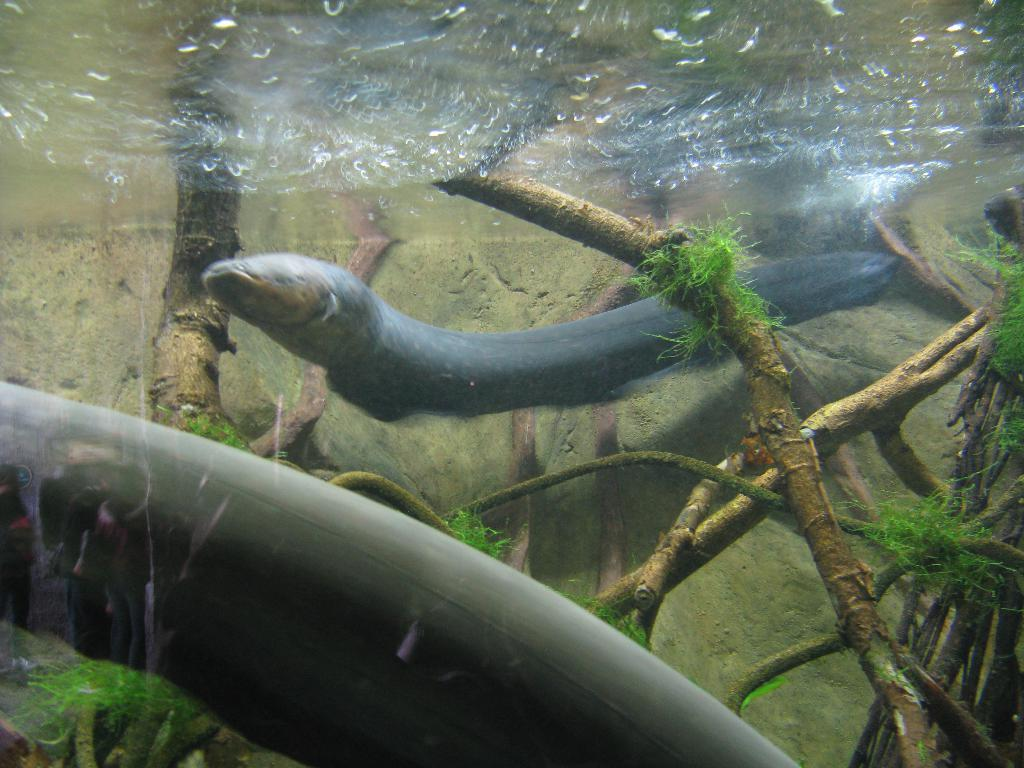Where was the image taken? The image is taken inside the water. What is the main subject in the center of the image? There is an animal in the center of the image. What can be seen growing in the water? Tree roots are visible in the image. What type of vegetation is present in the image? There is grass in the image. What sound can be heard coming from the sticks in the image? There are no sticks present in the image, so no sound can be heard from them. 